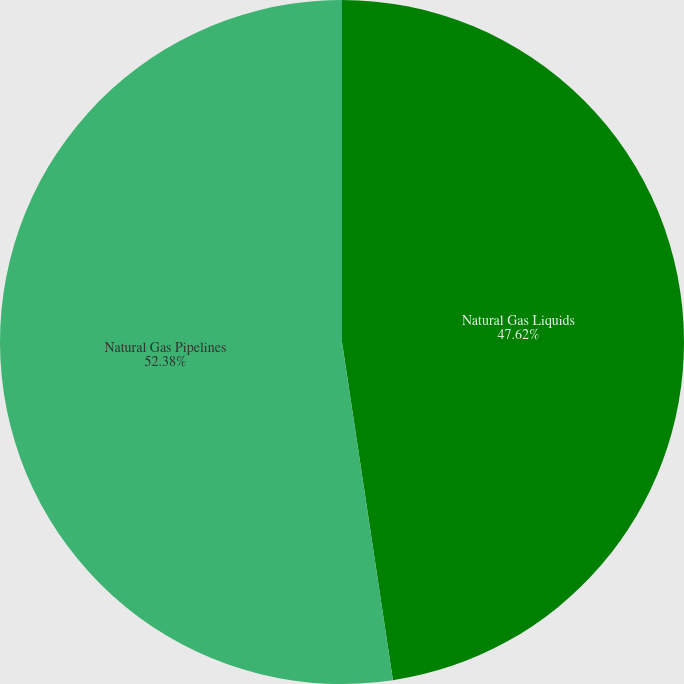Convert chart. <chart><loc_0><loc_0><loc_500><loc_500><pie_chart><fcel>Natural Gas Liquids<fcel>Natural Gas Pipelines<nl><fcel>47.62%<fcel>52.38%<nl></chart> 